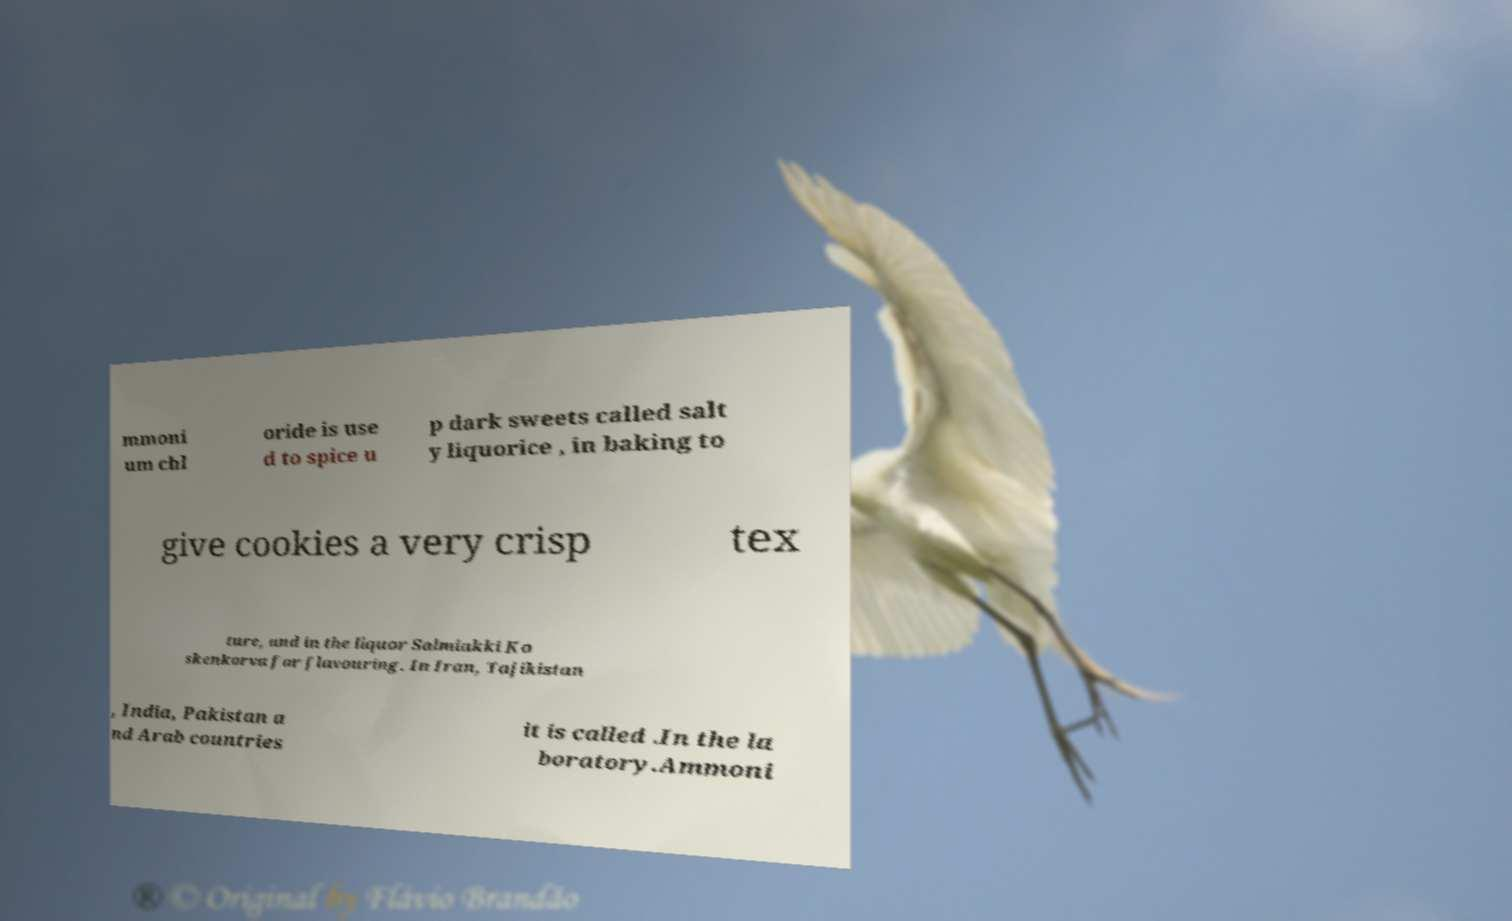I need the written content from this picture converted into text. Can you do that? mmoni um chl oride is use d to spice u p dark sweets called salt y liquorice , in baking to give cookies a very crisp tex ture, and in the liquor Salmiakki Ko skenkorva for flavouring. In Iran, Tajikistan , India, Pakistan a nd Arab countries it is called .In the la boratory.Ammoni 